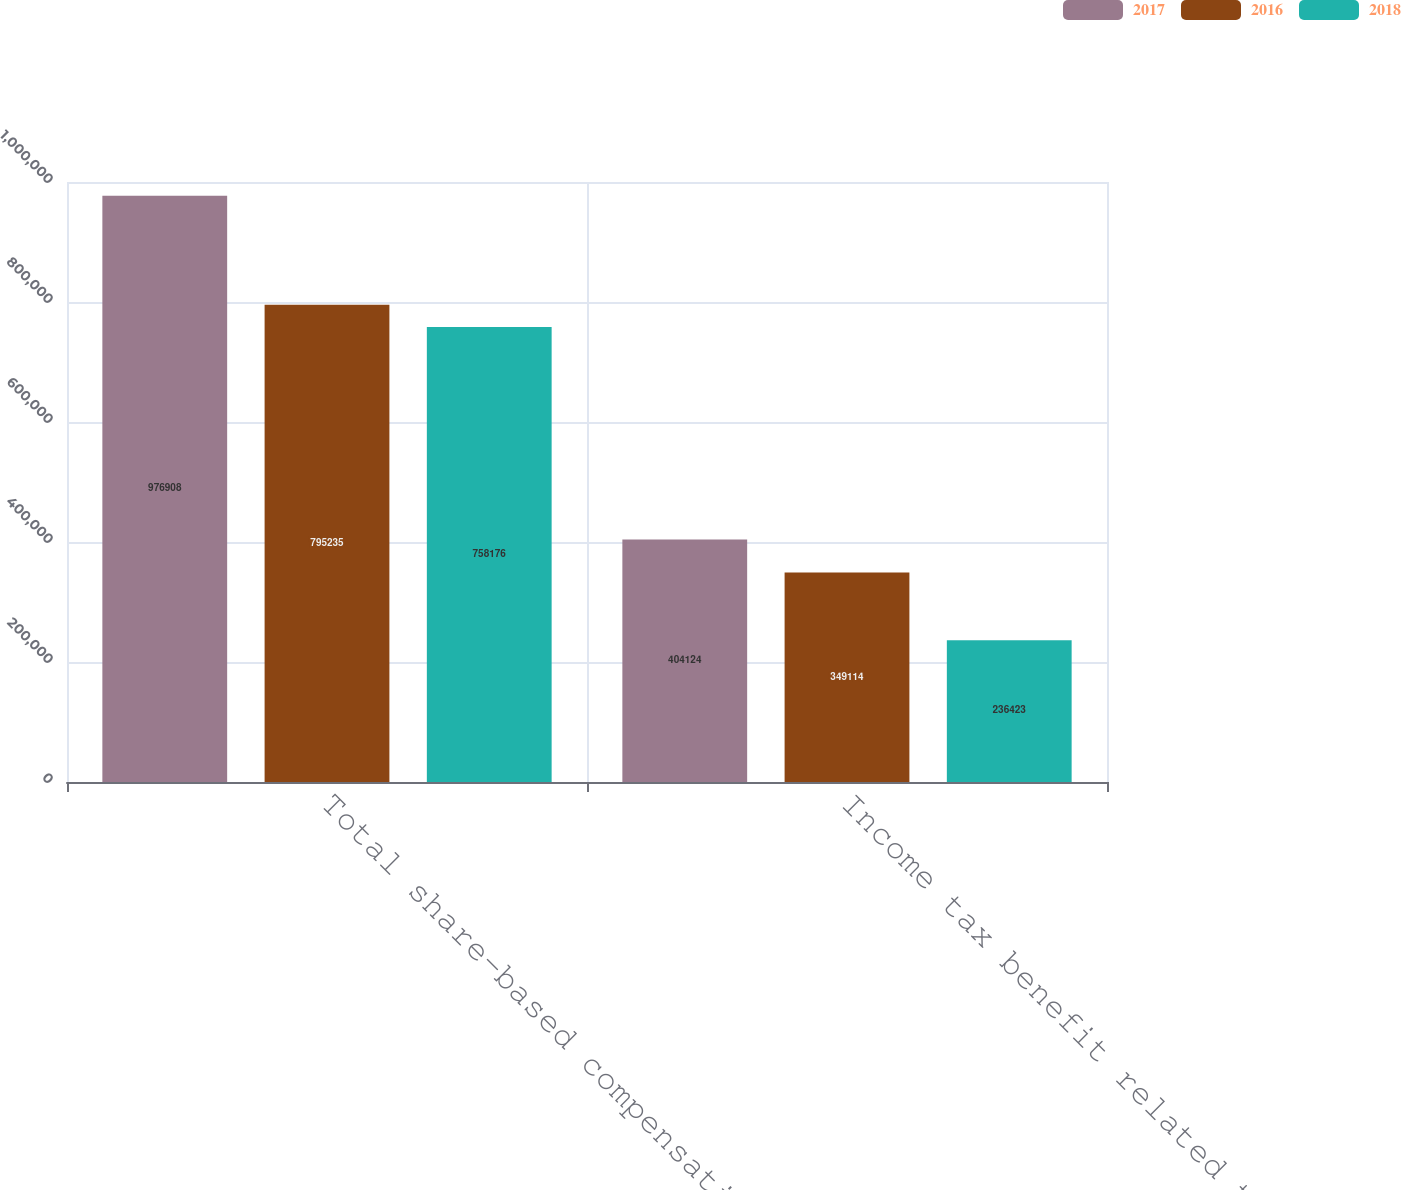Convert chart to OTSL. <chart><loc_0><loc_0><loc_500><loc_500><stacked_bar_chart><ecel><fcel>Total share-based compensation<fcel>Income tax benefit related to<nl><fcel>2017<fcel>976908<fcel>404124<nl><fcel>2016<fcel>795235<fcel>349114<nl><fcel>2018<fcel>758176<fcel>236423<nl></chart> 